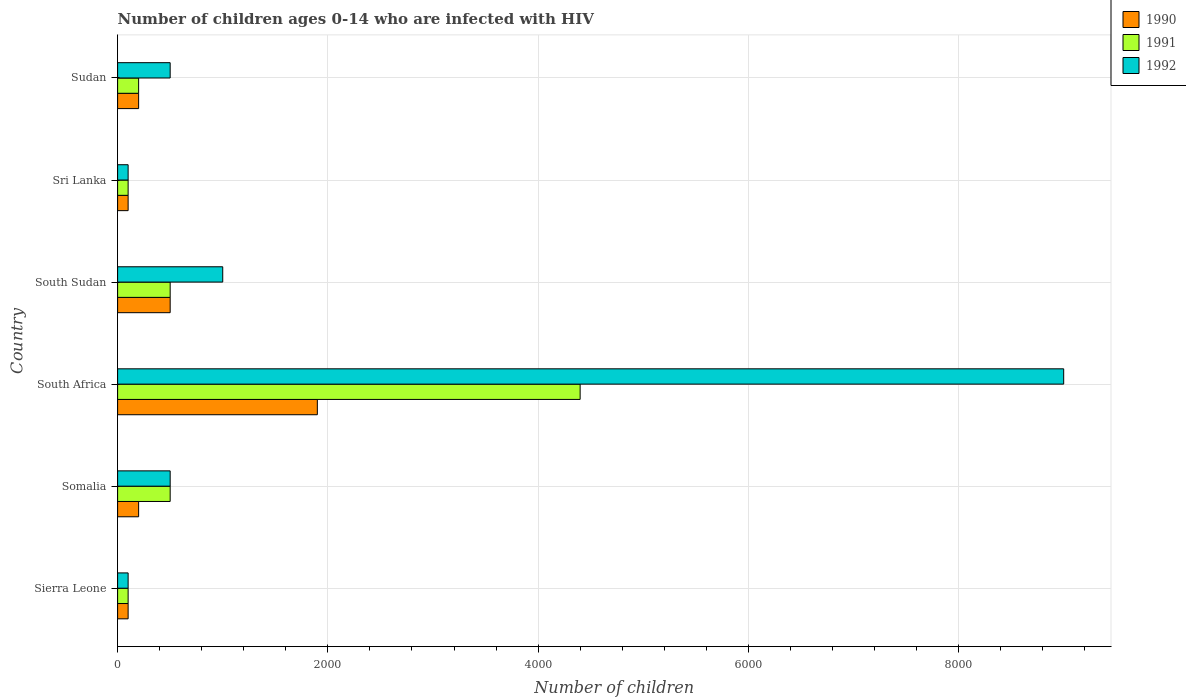How many groups of bars are there?
Make the answer very short. 6. Are the number of bars on each tick of the Y-axis equal?
Your answer should be compact. Yes. How many bars are there on the 5th tick from the bottom?
Ensure brevity in your answer.  3. What is the label of the 5th group of bars from the top?
Keep it short and to the point. Somalia. What is the number of HIV infected children in 1991 in South Sudan?
Offer a very short reply. 500. Across all countries, what is the maximum number of HIV infected children in 1992?
Make the answer very short. 9000. Across all countries, what is the minimum number of HIV infected children in 1991?
Offer a very short reply. 100. In which country was the number of HIV infected children in 1990 maximum?
Provide a short and direct response. South Africa. In which country was the number of HIV infected children in 1992 minimum?
Keep it short and to the point. Sierra Leone. What is the total number of HIV infected children in 1990 in the graph?
Provide a succinct answer. 3000. What is the difference between the number of HIV infected children in 1991 in Sri Lanka and the number of HIV infected children in 1990 in Sierra Leone?
Your response must be concise. 0. What is the average number of HIV infected children in 1992 per country?
Keep it short and to the point. 1866.67. What is the difference between the number of HIV infected children in 1990 and number of HIV infected children in 1991 in Somalia?
Ensure brevity in your answer.  -300. In how many countries, is the number of HIV infected children in 1992 greater than 5600 ?
Provide a short and direct response. 1. Is the difference between the number of HIV infected children in 1990 in Sierra Leone and South Sudan greater than the difference between the number of HIV infected children in 1991 in Sierra Leone and South Sudan?
Offer a terse response. No. What is the difference between the highest and the second highest number of HIV infected children in 1991?
Keep it short and to the point. 3900. What is the difference between the highest and the lowest number of HIV infected children in 1992?
Give a very brief answer. 8900. Is the sum of the number of HIV infected children in 1991 in South Africa and South Sudan greater than the maximum number of HIV infected children in 1992 across all countries?
Your answer should be compact. No. What does the 1st bar from the bottom in Sierra Leone represents?
Give a very brief answer. 1990. Is it the case that in every country, the sum of the number of HIV infected children in 1990 and number of HIV infected children in 1992 is greater than the number of HIV infected children in 1991?
Your answer should be compact. Yes. How many bars are there?
Ensure brevity in your answer.  18. Are all the bars in the graph horizontal?
Your answer should be compact. Yes. Are the values on the major ticks of X-axis written in scientific E-notation?
Keep it short and to the point. No. Where does the legend appear in the graph?
Ensure brevity in your answer.  Top right. What is the title of the graph?
Your answer should be very brief. Number of children ages 0-14 who are infected with HIV. Does "1963" appear as one of the legend labels in the graph?
Give a very brief answer. No. What is the label or title of the X-axis?
Give a very brief answer. Number of children. What is the label or title of the Y-axis?
Make the answer very short. Country. What is the Number of children of 1990 in Sierra Leone?
Provide a succinct answer. 100. What is the Number of children in 1991 in Sierra Leone?
Ensure brevity in your answer.  100. What is the Number of children of 1992 in Sierra Leone?
Provide a short and direct response. 100. What is the Number of children of 1991 in Somalia?
Offer a terse response. 500. What is the Number of children in 1992 in Somalia?
Provide a short and direct response. 500. What is the Number of children in 1990 in South Africa?
Provide a short and direct response. 1900. What is the Number of children of 1991 in South Africa?
Your response must be concise. 4400. What is the Number of children in 1992 in South Africa?
Offer a terse response. 9000. What is the Number of children in 1990 in South Sudan?
Offer a terse response. 500. What is the Number of children in 1991 in South Sudan?
Make the answer very short. 500. What is the Number of children in 1992 in South Sudan?
Keep it short and to the point. 1000. What is the Number of children of 1991 in Sri Lanka?
Give a very brief answer. 100. What is the Number of children in 1992 in Sri Lanka?
Your answer should be very brief. 100. What is the Number of children of 1990 in Sudan?
Your answer should be very brief. 200. What is the Number of children in 1991 in Sudan?
Your response must be concise. 200. What is the Number of children in 1992 in Sudan?
Ensure brevity in your answer.  500. Across all countries, what is the maximum Number of children of 1990?
Offer a very short reply. 1900. Across all countries, what is the maximum Number of children in 1991?
Offer a terse response. 4400. Across all countries, what is the maximum Number of children of 1992?
Provide a short and direct response. 9000. Across all countries, what is the minimum Number of children in 1991?
Your answer should be very brief. 100. Across all countries, what is the minimum Number of children in 1992?
Your answer should be compact. 100. What is the total Number of children of 1990 in the graph?
Offer a terse response. 3000. What is the total Number of children of 1991 in the graph?
Give a very brief answer. 5800. What is the total Number of children of 1992 in the graph?
Keep it short and to the point. 1.12e+04. What is the difference between the Number of children of 1990 in Sierra Leone and that in Somalia?
Your answer should be very brief. -100. What is the difference between the Number of children of 1991 in Sierra Leone and that in Somalia?
Your answer should be very brief. -400. What is the difference between the Number of children in 1992 in Sierra Leone and that in Somalia?
Give a very brief answer. -400. What is the difference between the Number of children in 1990 in Sierra Leone and that in South Africa?
Give a very brief answer. -1800. What is the difference between the Number of children in 1991 in Sierra Leone and that in South Africa?
Give a very brief answer. -4300. What is the difference between the Number of children of 1992 in Sierra Leone and that in South Africa?
Ensure brevity in your answer.  -8900. What is the difference between the Number of children of 1990 in Sierra Leone and that in South Sudan?
Ensure brevity in your answer.  -400. What is the difference between the Number of children in 1991 in Sierra Leone and that in South Sudan?
Provide a succinct answer. -400. What is the difference between the Number of children in 1992 in Sierra Leone and that in South Sudan?
Provide a succinct answer. -900. What is the difference between the Number of children of 1990 in Sierra Leone and that in Sri Lanka?
Your answer should be compact. 0. What is the difference between the Number of children of 1992 in Sierra Leone and that in Sri Lanka?
Make the answer very short. 0. What is the difference between the Number of children in 1990 in Sierra Leone and that in Sudan?
Keep it short and to the point. -100. What is the difference between the Number of children of 1991 in Sierra Leone and that in Sudan?
Provide a succinct answer. -100. What is the difference between the Number of children in 1992 in Sierra Leone and that in Sudan?
Ensure brevity in your answer.  -400. What is the difference between the Number of children of 1990 in Somalia and that in South Africa?
Give a very brief answer. -1700. What is the difference between the Number of children of 1991 in Somalia and that in South Africa?
Make the answer very short. -3900. What is the difference between the Number of children of 1992 in Somalia and that in South Africa?
Provide a succinct answer. -8500. What is the difference between the Number of children of 1990 in Somalia and that in South Sudan?
Make the answer very short. -300. What is the difference between the Number of children of 1992 in Somalia and that in South Sudan?
Provide a succinct answer. -500. What is the difference between the Number of children in 1990 in Somalia and that in Sri Lanka?
Give a very brief answer. 100. What is the difference between the Number of children of 1991 in Somalia and that in Sri Lanka?
Your answer should be compact. 400. What is the difference between the Number of children in 1992 in Somalia and that in Sri Lanka?
Offer a very short reply. 400. What is the difference between the Number of children in 1990 in Somalia and that in Sudan?
Your response must be concise. 0. What is the difference between the Number of children of 1991 in Somalia and that in Sudan?
Your response must be concise. 300. What is the difference between the Number of children of 1992 in Somalia and that in Sudan?
Keep it short and to the point. 0. What is the difference between the Number of children of 1990 in South Africa and that in South Sudan?
Offer a terse response. 1400. What is the difference between the Number of children in 1991 in South Africa and that in South Sudan?
Keep it short and to the point. 3900. What is the difference between the Number of children in 1992 in South Africa and that in South Sudan?
Make the answer very short. 8000. What is the difference between the Number of children in 1990 in South Africa and that in Sri Lanka?
Provide a succinct answer. 1800. What is the difference between the Number of children of 1991 in South Africa and that in Sri Lanka?
Your answer should be compact. 4300. What is the difference between the Number of children of 1992 in South Africa and that in Sri Lanka?
Offer a very short reply. 8900. What is the difference between the Number of children in 1990 in South Africa and that in Sudan?
Your answer should be very brief. 1700. What is the difference between the Number of children in 1991 in South Africa and that in Sudan?
Give a very brief answer. 4200. What is the difference between the Number of children in 1992 in South Africa and that in Sudan?
Make the answer very short. 8500. What is the difference between the Number of children of 1992 in South Sudan and that in Sri Lanka?
Provide a short and direct response. 900. What is the difference between the Number of children of 1990 in South Sudan and that in Sudan?
Make the answer very short. 300. What is the difference between the Number of children in 1991 in South Sudan and that in Sudan?
Provide a short and direct response. 300. What is the difference between the Number of children in 1990 in Sri Lanka and that in Sudan?
Make the answer very short. -100. What is the difference between the Number of children in 1991 in Sri Lanka and that in Sudan?
Make the answer very short. -100. What is the difference between the Number of children of 1992 in Sri Lanka and that in Sudan?
Offer a very short reply. -400. What is the difference between the Number of children of 1990 in Sierra Leone and the Number of children of 1991 in Somalia?
Your answer should be compact. -400. What is the difference between the Number of children of 1990 in Sierra Leone and the Number of children of 1992 in Somalia?
Provide a succinct answer. -400. What is the difference between the Number of children of 1991 in Sierra Leone and the Number of children of 1992 in Somalia?
Ensure brevity in your answer.  -400. What is the difference between the Number of children of 1990 in Sierra Leone and the Number of children of 1991 in South Africa?
Ensure brevity in your answer.  -4300. What is the difference between the Number of children of 1990 in Sierra Leone and the Number of children of 1992 in South Africa?
Make the answer very short. -8900. What is the difference between the Number of children in 1991 in Sierra Leone and the Number of children in 1992 in South Africa?
Your answer should be compact. -8900. What is the difference between the Number of children of 1990 in Sierra Leone and the Number of children of 1991 in South Sudan?
Provide a short and direct response. -400. What is the difference between the Number of children of 1990 in Sierra Leone and the Number of children of 1992 in South Sudan?
Provide a short and direct response. -900. What is the difference between the Number of children of 1991 in Sierra Leone and the Number of children of 1992 in South Sudan?
Provide a succinct answer. -900. What is the difference between the Number of children of 1991 in Sierra Leone and the Number of children of 1992 in Sri Lanka?
Give a very brief answer. 0. What is the difference between the Number of children of 1990 in Sierra Leone and the Number of children of 1991 in Sudan?
Offer a terse response. -100. What is the difference between the Number of children in 1990 in Sierra Leone and the Number of children in 1992 in Sudan?
Keep it short and to the point. -400. What is the difference between the Number of children of 1991 in Sierra Leone and the Number of children of 1992 in Sudan?
Provide a succinct answer. -400. What is the difference between the Number of children of 1990 in Somalia and the Number of children of 1991 in South Africa?
Your response must be concise. -4200. What is the difference between the Number of children of 1990 in Somalia and the Number of children of 1992 in South Africa?
Make the answer very short. -8800. What is the difference between the Number of children in 1991 in Somalia and the Number of children in 1992 in South Africa?
Provide a short and direct response. -8500. What is the difference between the Number of children of 1990 in Somalia and the Number of children of 1991 in South Sudan?
Give a very brief answer. -300. What is the difference between the Number of children of 1990 in Somalia and the Number of children of 1992 in South Sudan?
Offer a very short reply. -800. What is the difference between the Number of children in 1991 in Somalia and the Number of children in 1992 in South Sudan?
Keep it short and to the point. -500. What is the difference between the Number of children of 1990 in Somalia and the Number of children of 1991 in Sri Lanka?
Provide a short and direct response. 100. What is the difference between the Number of children of 1990 in Somalia and the Number of children of 1992 in Sri Lanka?
Offer a terse response. 100. What is the difference between the Number of children of 1991 in Somalia and the Number of children of 1992 in Sri Lanka?
Offer a very short reply. 400. What is the difference between the Number of children of 1990 in Somalia and the Number of children of 1992 in Sudan?
Make the answer very short. -300. What is the difference between the Number of children of 1991 in Somalia and the Number of children of 1992 in Sudan?
Offer a very short reply. 0. What is the difference between the Number of children in 1990 in South Africa and the Number of children in 1991 in South Sudan?
Your answer should be compact. 1400. What is the difference between the Number of children of 1990 in South Africa and the Number of children of 1992 in South Sudan?
Offer a terse response. 900. What is the difference between the Number of children of 1991 in South Africa and the Number of children of 1992 in South Sudan?
Offer a terse response. 3400. What is the difference between the Number of children in 1990 in South Africa and the Number of children in 1991 in Sri Lanka?
Keep it short and to the point. 1800. What is the difference between the Number of children in 1990 in South Africa and the Number of children in 1992 in Sri Lanka?
Provide a short and direct response. 1800. What is the difference between the Number of children of 1991 in South Africa and the Number of children of 1992 in Sri Lanka?
Give a very brief answer. 4300. What is the difference between the Number of children of 1990 in South Africa and the Number of children of 1991 in Sudan?
Keep it short and to the point. 1700. What is the difference between the Number of children of 1990 in South Africa and the Number of children of 1992 in Sudan?
Your answer should be very brief. 1400. What is the difference between the Number of children of 1991 in South Africa and the Number of children of 1992 in Sudan?
Give a very brief answer. 3900. What is the difference between the Number of children of 1990 in South Sudan and the Number of children of 1992 in Sri Lanka?
Offer a very short reply. 400. What is the difference between the Number of children of 1991 in South Sudan and the Number of children of 1992 in Sri Lanka?
Give a very brief answer. 400. What is the difference between the Number of children in 1990 in South Sudan and the Number of children in 1991 in Sudan?
Offer a very short reply. 300. What is the difference between the Number of children of 1990 in South Sudan and the Number of children of 1992 in Sudan?
Make the answer very short. 0. What is the difference between the Number of children of 1991 in South Sudan and the Number of children of 1992 in Sudan?
Give a very brief answer. 0. What is the difference between the Number of children of 1990 in Sri Lanka and the Number of children of 1991 in Sudan?
Your answer should be very brief. -100. What is the difference between the Number of children in 1990 in Sri Lanka and the Number of children in 1992 in Sudan?
Your answer should be compact. -400. What is the difference between the Number of children in 1991 in Sri Lanka and the Number of children in 1992 in Sudan?
Your response must be concise. -400. What is the average Number of children of 1990 per country?
Offer a very short reply. 500. What is the average Number of children in 1991 per country?
Provide a short and direct response. 966.67. What is the average Number of children of 1992 per country?
Ensure brevity in your answer.  1866.67. What is the difference between the Number of children of 1991 and Number of children of 1992 in Sierra Leone?
Your answer should be compact. 0. What is the difference between the Number of children of 1990 and Number of children of 1991 in Somalia?
Keep it short and to the point. -300. What is the difference between the Number of children in 1990 and Number of children in 1992 in Somalia?
Your answer should be compact. -300. What is the difference between the Number of children in 1990 and Number of children in 1991 in South Africa?
Ensure brevity in your answer.  -2500. What is the difference between the Number of children of 1990 and Number of children of 1992 in South Africa?
Give a very brief answer. -7100. What is the difference between the Number of children in 1991 and Number of children in 1992 in South Africa?
Provide a short and direct response. -4600. What is the difference between the Number of children of 1990 and Number of children of 1991 in South Sudan?
Offer a very short reply. 0. What is the difference between the Number of children of 1990 and Number of children of 1992 in South Sudan?
Offer a very short reply. -500. What is the difference between the Number of children in 1991 and Number of children in 1992 in South Sudan?
Ensure brevity in your answer.  -500. What is the difference between the Number of children of 1990 and Number of children of 1992 in Sri Lanka?
Your response must be concise. 0. What is the difference between the Number of children in 1991 and Number of children in 1992 in Sri Lanka?
Your answer should be very brief. 0. What is the difference between the Number of children in 1990 and Number of children in 1991 in Sudan?
Make the answer very short. 0. What is the difference between the Number of children in 1990 and Number of children in 1992 in Sudan?
Keep it short and to the point. -300. What is the difference between the Number of children of 1991 and Number of children of 1992 in Sudan?
Your answer should be compact. -300. What is the ratio of the Number of children of 1990 in Sierra Leone to that in Somalia?
Offer a very short reply. 0.5. What is the ratio of the Number of children in 1991 in Sierra Leone to that in Somalia?
Keep it short and to the point. 0.2. What is the ratio of the Number of children in 1992 in Sierra Leone to that in Somalia?
Provide a succinct answer. 0.2. What is the ratio of the Number of children in 1990 in Sierra Leone to that in South Africa?
Keep it short and to the point. 0.05. What is the ratio of the Number of children in 1991 in Sierra Leone to that in South Africa?
Ensure brevity in your answer.  0.02. What is the ratio of the Number of children in 1992 in Sierra Leone to that in South Africa?
Your answer should be very brief. 0.01. What is the ratio of the Number of children of 1990 in Sierra Leone to that in South Sudan?
Keep it short and to the point. 0.2. What is the ratio of the Number of children in 1991 in Sierra Leone to that in South Sudan?
Offer a terse response. 0.2. What is the ratio of the Number of children in 1990 in Sierra Leone to that in Sri Lanka?
Your response must be concise. 1. What is the ratio of the Number of children in 1991 in Sierra Leone to that in Sudan?
Give a very brief answer. 0.5. What is the ratio of the Number of children of 1992 in Sierra Leone to that in Sudan?
Provide a short and direct response. 0.2. What is the ratio of the Number of children in 1990 in Somalia to that in South Africa?
Make the answer very short. 0.11. What is the ratio of the Number of children in 1991 in Somalia to that in South Africa?
Your answer should be compact. 0.11. What is the ratio of the Number of children in 1992 in Somalia to that in South Africa?
Give a very brief answer. 0.06. What is the ratio of the Number of children in 1991 in Somalia to that in South Sudan?
Provide a short and direct response. 1. What is the ratio of the Number of children in 1990 in Somalia to that in Sudan?
Ensure brevity in your answer.  1. What is the ratio of the Number of children in 1992 in Somalia to that in Sudan?
Your answer should be compact. 1. What is the ratio of the Number of children of 1990 in South Africa to that in Sri Lanka?
Make the answer very short. 19. What is the ratio of the Number of children of 1991 in South Africa to that in Sri Lanka?
Your answer should be compact. 44. What is the ratio of the Number of children of 1992 in South Africa to that in Sri Lanka?
Keep it short and to the point. 90. What is the ratio of the Number of children of 1991 in South Africa to that in Sudan?
Provide a succinct answer. 22. What is the ratio of the Number of children of 1992 in South Sudan to that in Sri Lanka?
Give a very brief answer. 10. What is the ratio of the Number of children in 1990 in South Sudan to that in Sudan?
Keep it short and to the point. 2.5. What is the ratio of the Number of children in 1991 in South Sudan to that in Sudan?
Make the answer very short. 2.5. What is the ratio of the Number of children of 1992 in South Sudan to that in Sudan?
Offer a terse response. 2. What is the ratio of the Number of children of 1991 in Sri Lanka to that in Sudan?
Ensure brevity in your answer.  0.5. What is the ratio of the Number of children in 1992 in Sri Lanka to that in Sudan?
Offer a very short reply. 0.2. What is the difference between the highest and the second highest Number of children in 1990?
Give a very brief answer. 1400. What is the difference between the highest and the second highest Number of children of 1991?
Your response must be concise. 3900. What is the difference between the highest and the second highest Number of children in 1992?
Your answer should be very brief. 8000. What is the difference between the highest and the lowest Number of children of 1990?
Ensure brevity in your answer.  1800. What is the difference between the highest and the lowest Number of children in 1991?
Offer a terse response. 4300. What is the difference between the highest and the lowest Number of children in 1992?
Your answer should be compact. 8900. 